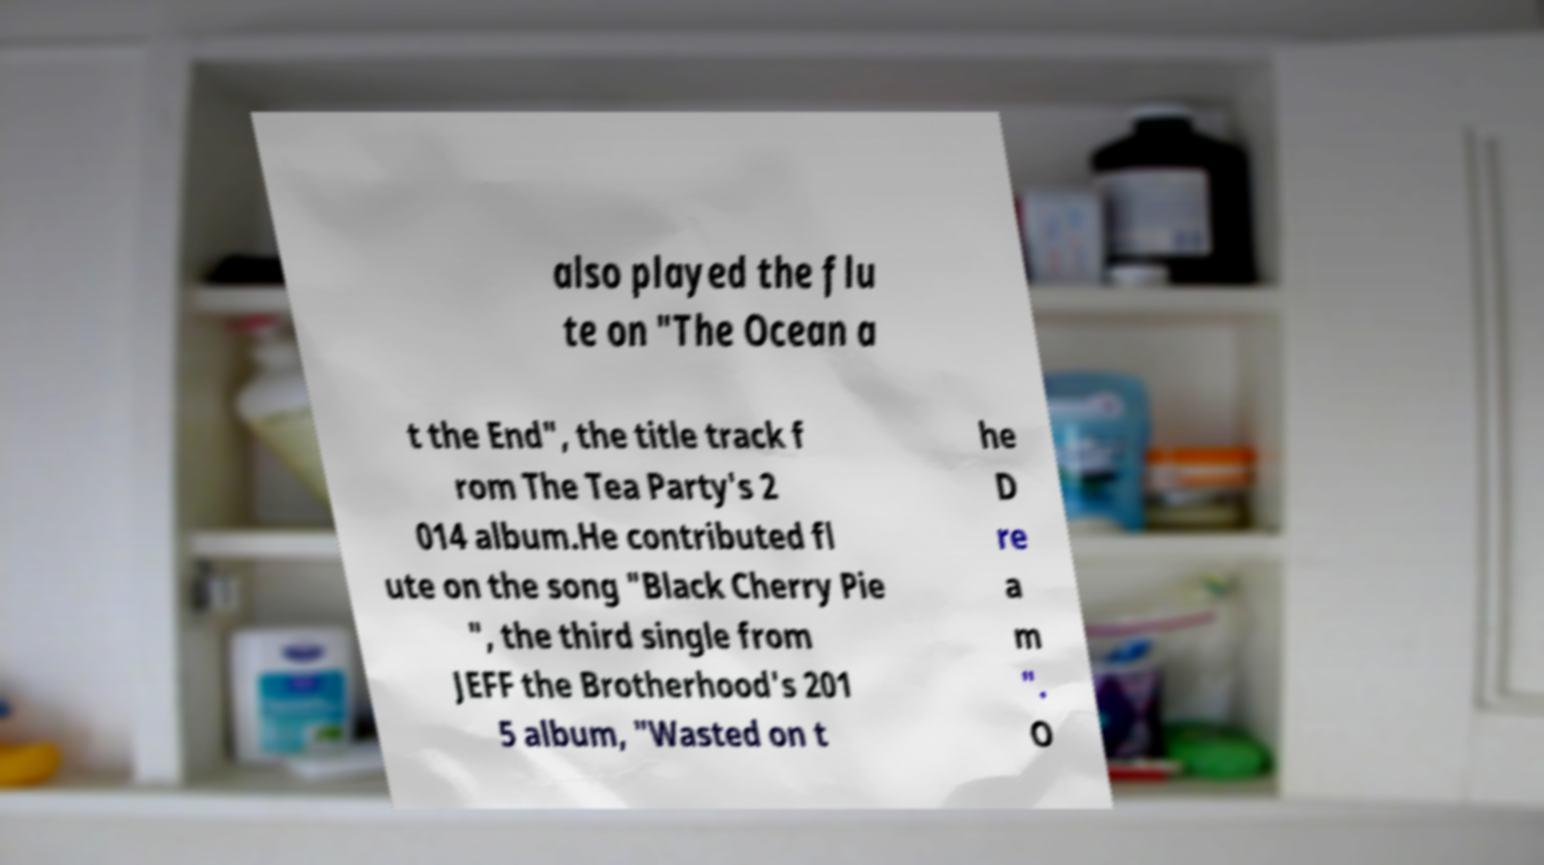Please read and relay the text visible in this image. What does it say? also played the flu te on "The Ocean a t the End", the title track f rom The Tea Party's 2 014 album.He contributed fl ute on the song "Black Cherry Pie ", the third single from JEFF the Brotherhood's 201 5 album, "Wasted on t he D re a m ". O 